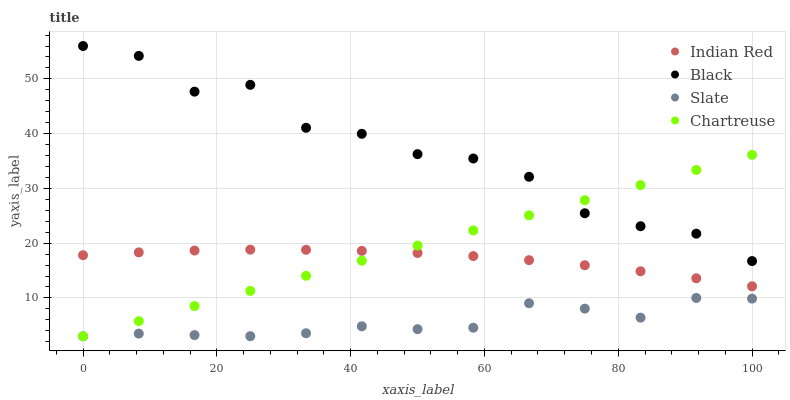Does Slate have the minimum area under the curve?
Answer yes or no. Yes. Does Black have the maximum area under the curve?
Answer yes or no. Yes. Does Chartreuse have the minimum area under the curve?
Answer yes or no. No. Does Chartreuse have the maximum area under the curve?
Answer yes or no. No. Is Chartreuse the smoothest?
Answer yes or no. Yes. Is Black the roughest?
Answer yes or no. Yes. Is Black the smoothest?
Answer yes or no. No. Is Chartreuse the roughest?
Answer yes or no. No. Does Slate have the lowest value?
Answer yes or no. Yes. Does Black have the lowest value?
Answer yes or no. No. Does Black have the highest value?
Answer yes or no. Yes. Does Chartreuse have the highest value?
Answer yes or no. No. Is Slate less than Indian Red?
Answer yes or no. Yes. Is Black greater than Indian Red?
Answer yes or no. Yes. Does Black intersect Chartreuse?
Answer yes or no. Yes. Is Black less than Chartreuse?
Answer yes or no. No. Is Black greater than Chartreuse?
Answer yes or no. No. Does Slate intersect Indian Red?
Answer yes or no. No. 